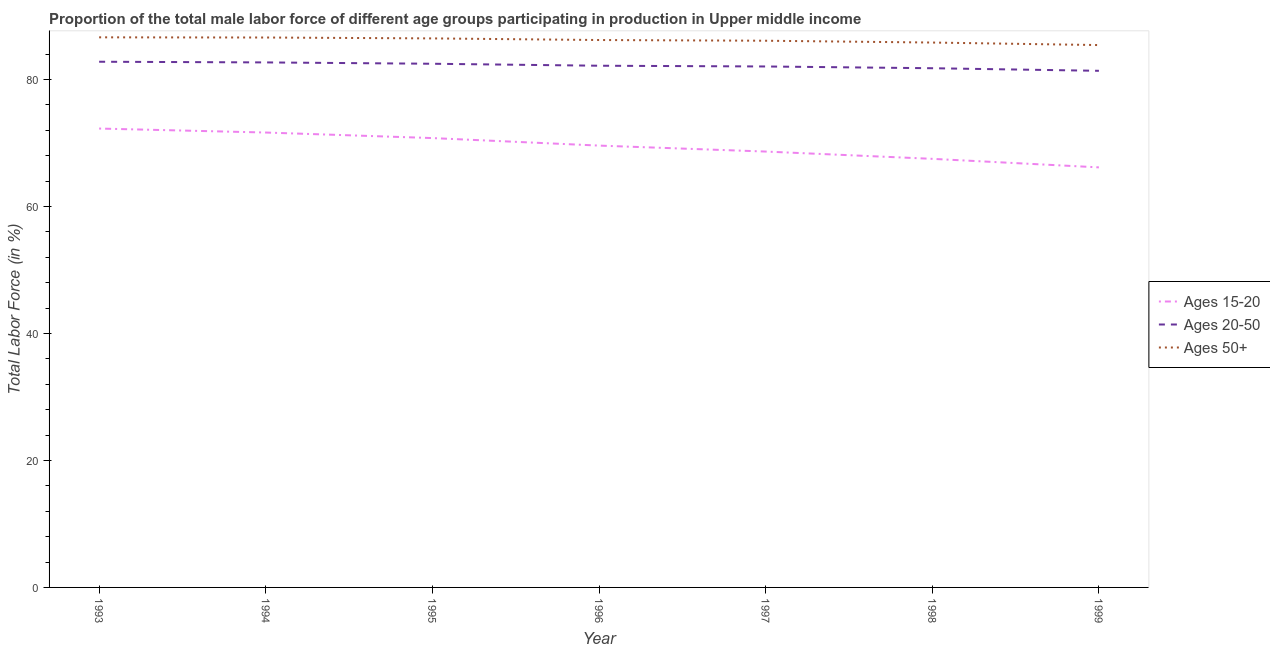What is the percentage of male labor force within the age group 20-50 in 1997?
Provide a short and direct response. 82.04. Across all years, what is the maximum percentage of male labor force above age 50?
Your answer should be compact. 86.63. Across all years, what is the minimum percentage of male labor force within the age group 20-50?
Your answer should be compact. 81.36. In which year was the percentage of male labor force within the age group 15-20 maximum?
Offer a very short reply. 1993. In which year was the percentage of male labor force above age 50 minimum?
Provide a succinct answer. 1999. What is the total percentage of male labor force within the age group 20-50 in the graph?
Provide a short and direct response. 575.24. What is the difference between the percentage of male labor force above age 50 in 1994 and that in 1996?
Your answer should be compact. 0.4. What is the difference between the percentage of male labor force above age 50 in 1994 and the percentage of male labor force within the age group 15-20 in 1993?
Offer a terse response. 14.34. What is the average percentage of male labor force above age 50 per year?
Offer a very short reply. 86.17. In the year 1995, what is the difference between the percentage of male labor force above age 50 and percentage of male labor force within the age group 15-20?
Provide a succinct answer. 15.7. What is the ratio of the percentage of male labor force above age 50 in 1998 to that in 1999?
Offer a terse response. 1. Is the percentage of male labor force within the age group 20-50 in 1997 less than that in 1999?
Offer a very short reply. No. What is the difference between the highest and the second highest percentage of male labor force above age 50?
Your answer should be very brief. 0.03. What is the difference between the highest and the lowest percentage of male labor force within the age group 20-50?
Ensure brevity in your answer.  1.43. Is the sum of the percentage of male labor force within the age group 15-20 in 1993 and 1999 greater than the maximum percentage of male labor force within the age group 20-50 across all years?
Your response must be concise. Yes. Does the percentage of male labor force within the age group 15-20 monotonically increase over the years?
Ensure brevity in your answer.  No. Is the percentage of male labor force within the age group 15-20 strictly greater than the percentage of male labor force within the age group 20-50 over the years?
Make the answer very short. No. Is the percentage of male labor force within the age group 20-50 strictly less than the percentage of male labor force above age 50 over the years?
Give a very brief answer. Yes. How many years are there in the graph?
Make the answer very short. 7. What is the difference between two consecutive major ticks on the Y-axis?
Your answer should be very brief. 20. Does the graph contain any zero values?
Give a very brief answer. No. How are the legend labels stacked?
Ensure brevity in your answer.  Vertical. What is the title of the graph?
Offer a terse response. Proportion of the total male labor force of different age groups participating in production in Upper middle income. What is the label or title of the X-axis?
Offer a terse response. Year. What is the Total Labor Force (in %) of Ages 15-20 in 1993?
Keep it short and to the point. 72.26. What is the Total Labor Force (in %) of Ages 20-50 in 1993?
Keep it short and to the point. 82.78. What is the Total Labor Force (in %) in Ages 50+ in 1993?
Give a very brief answer. 86.63. What is the Total Labor Force (in %) of Ages 15-20 in 1994?
Provide a short and direct response. 71.64. What is the Total Labor Force (in %) of Ages 20-50 in 1994?
Ensure brevity in your answer.  82.68. What is the Total Labor Force (in %) of Ages 50+ in 1994?
Your response must be concise. 86.6. What is the Total Labor Force (in %) of Ages 15-20 in 1995?
Provide a short and direct response. 70.76. What is the Total Labor Force (in %) of Ages 20-50 in 1995?
Offer a terse response. 82.47. What is the Total Labor Force (in %) in Ages 50+ in 1995?
Your answer should be very brief. 86.46. What is the Total Labor Force (in %) of Ages 15-20 in 1996?
Give a very brief answer. 69.58. What is the Total Labor Force (in %) of Ages 20-50 in 1996?
Your answer should be compact. 82.16. What is the Total Labor Force (in %) in Ages 50+ in 1996?
Your answer should be compact. 86.2. What is the Total Labor Force (in %) of Ages 15-20 in 1997?
Give a very brief answer. 68.64. What is the Total Labor Force (in %) of Ages 20-50 in 1997?
Your answer should be very brief. 82.04. What is the Total Labor Force (in %) of Ages 50+ in 1997?
Give a very brief answer. 86.09. What is the Total Labor Force (in %) in Ages 15-20 in 1998?
Provide a short and direct response. 67.49. What is the Total Labor Force (in %) of Ages 20-50 in 1998?
Ensure brevity in your answer.  81.76. What is the Total Labor Force (in %) in Ages 50+ in 1998?
Provide a succinct answer. 85.81. What is the Total Labor Force (in %) in Ages 15-20 in 1999?
Your answer should be very brief. 66.15. What is the Total Labor Force (in %) of Ages 20-50 in 1999?
Offer a terse response. 81.36. What is the Total Labor Force (in %) of Ages 50+ in 1999?
Keep it short and to the point. 85.41. Across all years, what is the maximum Total Labor Force (in %) of Ages 15-20?
Your answer should be very brief. 72.26. Across all years, what is the maximum Total Labor Force (in %) in Ages 20-50?
Your answer should be compact. 82.78. Across all years, what is the maximum Total Labor Force (in %) of Ages 50+?
Your answer should be very brief. 86.63. Across all years, what is the minimum Total Labor Force (in %) in Ages 15-20?
Offer a terse response. 66.15. Across all years, what is the minimum Total Labor Force (in %) of Ages 20-50?
Your answer should be very brief. 81.36. Across all years, what is the minimum Total Labor Force (in %) of Ages 50+?
Offer a very short reply. 85.41. What is the total Total Labor Force (in %) of Ages 15-20 in the graph?
Provide a short and direct response. 486.52. What is the total Total Labor Force (in %) of Ages 20-50 in the graph?
Offer a terse response. 575.24. What is the total Total Labor Force (in %) in Ages 50+ in the graph?
Offer a very short reply. 603.19. What is the difference between the Total Labor Force (in %) of Ages 15-20 in 1993 and that in 1994?
Keep it short and to the point. 0.63. What is the difference between the Total Labor Force (in %) in Ages 20-50 in 1993 and that in 1994?
Keep it short and to the point. 0.11. What is the difference between the Total Labor Force (in %) of Ages 50+ in 1993 and that in 1994?
Ensure brevity in your answer.  0.03. What is the difference between the Total Labor Force (in %) in Ages 15-20 in 1993 and that in 1995?
Keep it short and to the point. 1.5. What is the difference between the Total Labor Force (in %) in Ages 20-50 in 1993 and that in 1995?
Your answer should be very brief. 0.32. What is the difference between the Total Labor Force (in %) of Ages 50+ in 1993 and that in 1995?
Offer a terse response. 0.17. What is the difference between the Total Labor Force (in %) in Ages 15-20 in 1993 and that in 1996?
Keep it short and to the point. 2.68. What is the difference between the Total Labor Force (in %) of Ages 20-50 in 1993 and that in 1996?
Offer a very short reply. 0.63. What is the difference between the Total Labor Force (in %) in Ages 50+ in 1993 and that in 1996?
Make the answer very short. 0.42. What is the difference between the Total Labor Force (in %) in Ages 15-20 in 1993 and that in 1997?
Provide a succinct answer. 3.62. What is the difference between the Total Labor Force (in %) of Ages 20-50 in 1993 and that in 1997?
Give a very brief answer. 0.75. What is the difference between the Total Labor Force (in %) in Ages 50+ in 1993 and that in 1997?
Keep it short and to the point. 0.54. What is the difference between the Total Labor Force (in %) of Ages 15-20 in 1993 and that in 1998?
Your answer should be very brief. 4.77. What is the difference between the Total Labor Force (in %) in Ages 20-50 in 1993 and that in 1998?
Your response must be concise. 1.02. What is the difference between the Total Labor Force (in %) in Ages 50+ in 1993 and that in 1998?
Your response must be concise. 0.82. What is the difference between the Total Labor Force (in %) in Ages 15-20 in 1993 and that in 1999?
Ensure brevity in your answer.  6.12. What is the difference between the Total Labor Force (in %) of Ages 20-50 in 1993 and that in 1999?
Provide a succinct answer. 1.43. What is the difference between the Total Labor Force (in %) of Ages 50+ in 1993 and that in 1999?
Your response must be concise. 1.22. What is the difference between the Total Labor Force (in %) of Ages 15-20 in 1994 and that in 1995?
Keep it short and to the point. 0.87. What is the difference between the Total Labor Force (in %) of Ages 20-50 in 1994 and that in 1995?
Give a very brief answer. 0.21. What is the difference between the Total Labor Force (in %) of Ages 50+ in 1994 and that in 1995?
Provide a short and direct response. 0.14. What is the difference between the Total Labor Force (in %) in Ages 15-20 in 1994 and that in 1996?
Your answer should be very brief. 2.06. What is the difference between the Total Labor Force (in %) of Ages 20-50 in 1994 and that in 1996?
Your answer should be very brief. 0.52. What is the difference between the Total Labor Force (in %) of Ages 50+ in 1994 and that in 1996?
Give a very brief answer. 0.4. What is the difference between the Total Labor Force (in %) in Ages 15-20 in 1994 and that in 1997?
Provide a succinct answer. 3. What is the difference between the Total Labor Force (in %) in Ages 20-50 in 1994 and that in 1997?
Offer a very short reply. 0.64. What is the difference between the Total Labor Force (in %) in Ages 50+ in 1994 and that in 1997?
Give a very brief answer. 0.51. What is the difference between the Total Labor Force (in %) of Ages 15-20 in 1994 and that in 1998?
Make the answer very short. 4.14. What is the difference between the Total Labor Force (in %) of Ages 20-50 in 1994 and that in 1998?
Ensure brevity in your answer.  0.92. What is the difference between the Total Labor Force (in %) of Ages 50+ in 1994 and that in 1998?
Keep it short and to the point. 0.79. What is the difference between the Total Labor Force (in %) in Ages 15-20 in 1994 and that in 1999?
Make the answer very short. 5.49. What is the difference between the Total Labor Force (in %) in Ages 20-50 in 1994 and that in 1999?
Offer a terse response. 1.32. What is the difference between the Total Labor Force (in %) in Ages 50+ in 1994 and that in 1999?
Offer a terse response. 1.19. What is the difference between the Total Labor Force (in %) of Ages 15-20 in 1995 and that in 1996?
Your answer should be compact. 1.18. What is the difference between the Total Labor Force (in %) of Ages 20-50 in 1995 and that in 1996?
Give a very brief answer. 0.31. What is the difference between the Total Labor Force (in %) in Ages 50+ in 1995 and that in 1996?
Your answer should be compact. 0.26. What is the difference between the Total Labor Force (in %) of Ages 15-20 in 1995 and that in 1997?
Provide a succinct answer. 2.12. What is the difference between the Total Labor Force (in %) of Ages 20-50 in 1995 and that in 1997?
Ensure brevity in your answer.  0.43. What is the difference between the Total Labor Force (in %) in Ages 50+ in 1995 and that in 1997?
Your answer should be very brief. 0.37. What is the difference between the Total Labor Force (in %) of Ages 15-20 in 1995 and that in 1998?
Give a very brief answer. 3.27. What is the difference between the Total Labor Force (in %) in Ages 20-50 in 1995 and that in 1998?
Offer a terse response. 0.7. What is the difference between the Total Labor Force (in %) in Ages 50+ in 1995 and that in 1998?
Keep it short and to the point. 0.65. What is the difference between the Total Labor Force (in %) in Ages 15-20 in 1995 and that in 1999?
Your answer should be compact. 4.62. What is the difference between the Total Labor Force (in %) in Ages 20-50 in 1995 and that in 1999?
Your answer should be very brief. 1.11. What is the difference between the Total Labor Force (in %) of Ages 50+ in 1995 and that in 1999?
Make the answer very short. 1.05. What is the difference between the Total Labor Force (in %) of Ages 15-20 in 1996 and that in 1997?
Your answer should be very brief. 0.94. What is the difference between the Total Labor Force (in %) of Ages 20-50 in 1996 and that in 1997?
Offer a terse response. 0.12. What is the difference between the Total Labor Force (in %) in Ages 50+ in 1996 and that in 1997?
Make the answer very short. 0.11. What is the difference between the Total Labor Force (in %) in Ages 15-20 in 1996 and that in 1998?
Offer a very short reply. 2.09. What is the difference between the Total Labor Force (in %) of Ages 20-50 in 1996 and that in 1998?
Give a very brief answer. 0.39. What is the difference between the Total Labor Force (in %) in Ages 50+ in 1996 and that in 1998?
Make the answer very short. 0.4. What is the difference between the Total Labor Force (in %) in Ages 15-20 in 1996 and that in 1999?
Offer a very short reply. 3.43. What is the difference between the Total Labor Force (in %) of Ages 20-50 in 1996 and that in 1999?
Keep it short and to the point. 0.8. What is the difference between the Total Labor Force (in %) in Ages 50+ in 1996 and that in 1999?
Give a very brief answer. 0.79. What is the difference between the Total Labor Force (in %) of Ages 15-20 in 1997 and that in 1998?
Your answer should be very brief. 1.15. What is the difference between the Total Labor Force (in %) of Ages 20-50 in 1997 and that in 1998?
Make the answer very short. 0.28. What is the difference between the Total Labor Force (in %) of Ages 50+ in 1997 and that in 1998?
Make the answer very short. 0.29. What is the difference between the Total Labor Force (in %) of Ages 15-20 in 1997 and that in 1999?
Make the answer very short. 2.49. What is the difference between the Total Labor Force (in %) of Ages 20-50 in 1997 and that in 1999?
Your answer should be very brief. 0.68. What is the difference between the Total Labor Force (in %) of Ages 50+ in 1997 and that in 1999?
Ensure brevity in your answer.  0.68. What is the difference between the Total Labor Force (in %) in Ages 15-20 in 1998 and that in 1999?
Offer a very short reply. 1.35. What is the difference between the Total Labor Force (in %) in Ages 20-50 in 1998 and that in 1999?
Your answer should be very brief. 0.41. What is the difference between the Total Labor Force (in %) in Ages 50+ in 1998 and that in 1999?
Provide a short and direct response. 0.4. What is the difference between the Total Labor Force (in %) of Ages 15-20 in 1993 and the Total Labor Force (in %) of Ages 20-50 in 1994?
Your answer should be compact. -10.41. What is the difference between the Total Labor Force (in %) of Ages 15-20 in 1993 and the Total Labor Force (in %) of Ages 50+ in 1994?
Make the answer very short. -14.34. What is the difference between the Total Labor Force (in %) in Ages 20-50 in 1993 and the Total Labor Force (in %) in Ages 50+ in 1994?
Your answer should be very brief. -3.81. What is the difference between the Total Labor Force (in %) of Ages 15-20 in 1993 and the Total Labor Force (in %) of Ages 20-50 in 1995?
Ensure brevity in your answer.  -10.2. What is the difference between the Total Labor Force (in %) of Ages 15-20 in 1993 and the Total Labor Force (in %) of Ages 50+ in 1995?
Your response must be concise. -14.2. What is the difference between the Total Labor Force (in %) of Ages 20-50 in 1993 and the Total Labor Force (in %) of Ages 50+ in 1995?
Keep it short and to the point. -3.67. What is the difference between the Total Labor Force (in %) of Ages 15-20 in 1993 and the Total Labor Force (in %) of Ages 20-50 in 1996?
Your response must be concise. -9.89. What is the difference between the Total Labor Force (in %) in Ages 15-20 in 1993 and the Total Labor Force (in %) in Ages 50+ in 1996?
Provide a short and direct response. -13.94. What is the difference between the Total Labor Force (in %) in Ages 20-50 in 1993 and the Total Labor Force (in %) in Ages 50+ in 1996?
Keep it short and to the point. -3.42. What is the difference between the Total Labor Force (in %) of Ages 15-20 in 1993 and the Total Labor Force (in %) of Ages 20-50 in 1997?
Your answer should be compact. -9.77. What is the difference between the Total Labor Force (in %) of Ages 15-20 in 1993 and the Total Labor Force (in %) of Ages 50+ in 1997?
Offer a terse response. -13.83. What is the difference between the Total Labor Force (in %) in Ages 20-50 in 1993 and the Total Labor Force (in %) in Ages 50+ in 1997?
Give a very brief answer. -3.31. What is the difference between the Total Labor Force (in %) of Ages 15-20 in 1993 and the Total Labor Force (in %) of Ages 20-50 in 1998?
Keep it short and to the point. -9.5. What is the difference between the Total Labor Force (in %) in Ages 15-20 in 1993 and the Total Labor Force (in %) in Ages 50+ in 1998?
Provide a succinct answer. -13.54. What is the difference between the Total Labor Force (in %) in Ages 20-50 in 1993 and the Total Labor Force (in %) in Ages 50+ in 1998?
Provide a short and direct response. -3.02. What is the difference between the Total Labor Force (in %) in Ages 15-20 in 1993 and the Total Labor Force (in %) in Ages 20-50 in 1999?
Keep it short and to the point. -9.09. What is the difference between the Total Labor Force (in %) in Ages 15-20 in 1993 and the Total Labor Force (in %) in Ages 50+ in 1999?
Offer a terse response. -13.15. What is the difference between the Total Labor Force (in %) in Ages 20-50 in 1993 and the Total Labor Force (in %) in Ages 50+ in 1999?
Make the answer very short. -2.62. What is the difference between the Total Labor Force (in %) in Ages 15-20 in 1994 and the Total Labor Force (in %) in Ages 20-50 in 1995?
Make the answer very short. -10.83. What is the difference between the Total Labor Force (in %) in Ages 15-20 in 1994 and the Total Labor Force (in %) in Ages 50+ in 1995?
Provide a succinct answer. -14.82. What is the difference between the Total Labor Force (in %) of Ages 20-50 in 1994 and the Total Labor Force (in %) of Ages 50+ in 1995?
Provide a short and direct response. -3.78. What is the difference between the Total Labor Force (in %) in Ages 15-20 in 1994 and the Total Labor Force (in %) in Ages 20-50 in 1996?
Make the answer very short. -10.52. What is the difference between the Total Labor Force (in %) of Ages 15-20 in 1994 and the Total Labor Force (in %) of Ages 50+ in 1996?
Make the answer very short. -14.57. What is the difference between the Total Labor Force (in %) of Ages 20-50 in 1994 and the Total Labor Force (in %) of Ages 50+ in 1996?
Provide a short and direct response. -3.53. What is the difference between the Total Labor Force (in %) of Ages 15-20 in 1994 and the Total Labor Force (in %) of Ages 20-50 in 1997?
Provide a succinct answer. -10.4. What is the difference between the Total Labor Force (in %) in Ages 15-20 in 1994 and the Total Labor Force (in %) in Ages 50+ in 1997?
Your answer should be very brief. -14.46. What is the difference between the Total Labor Force (in %) of Ages 20-50 in 1994 and the Total Labor Force (in %) of Ages 50+ in 1997?
Make the answer very short. -3.42. What is the difference between the Total Labor Force (in %) in Ages 15-20 in 1994 and the Total Labor Force (in %) in Ages 20-50 in 1998?
Your response must be concise. -10.13. What is the difference between the Total Labor Force (in %) in Ages 15-20 in 1994 and the Total Labor Force (in %) in Ages 50+ in 1998?
Offer a terse response. -14.17. What is the difference between the Total Labor Force (in %) in Ages 20-50 in 1994 and the Total Labor Force (in %) in Ages 50+ in 1998?
Make the answer very short. -3.13. What is the difference between the Total Labor Force (in %) of Ages 15-20 in 1994 and the Total Labor Force (in %) of Ages 20-50 in 1999?
Your response must be concise. -9.72. What is the difference between the Total Labor Force (in %) of Ages 15-20 in 1994 and the Total Labor Force (in %) of Ages 50+ in 1999?
Provide a succinct answer. -13.77. What is the difference between the Total Labor Force (in %) of Ages 20-50 in 1994 and the Total Labor Force (in %) of Ages 50+ in 1999?
Ensure brevity in your answer.  -2.73. What is the difference between the Total Labor Force (in %) of Ages 15-20 in 1995 and the Total Labor Force (in %) of Ages 20-50 in 1996?
Make the answer very short. -11.39. What is the difference between the Total Labor Force (in %) in Ages 15-20 in 1995 and the Total Labor Force (in %) in Ages 50+ in 1996?
Offer a very short reply. -15.44. What is the difference between the Total Labor Force (in %) of Ages 20-50 in 1995 and the Total Labor Force (in %) of Ages 50+ in 1996?
Provide a succinct answer. -3.74. What is the difference between the Total Labor Force (in %) in Ages 15-20 in 1995 and the Total Labor Force (in %) in Ages 20-50 in 1997?
Keep it short and to the point. -11.27. What is the difference between the Total Labor Force (in %) in Ages 15-20 in 1995 and the Total Labor Force (in %) in Ages 50+ in 1997?
Make the answer very short. -15.33. What is the difference between the Total Labor Force (in %) of Ages 20-50 in 1995 and the Total Labor Force (in %) of Ages 50+ in 1997?
Your answer should be very brief. -3.63. What is the difference between the Total Labor Force (in %) of Ages 15-20 in 1995 and the Total Labor Force (in %) of Ages 20-50 in 1998?
Offer a terse response. -11. What is the difference between the Total Labor Force (in %) of Ages 15-20 in 1995 and the Total Labor Force (in %) of Ages 50+ in 1998?
Your answer should be compact. -15.04. What is the difference between the Total Labor Force (in %) in Ages 20-50 in 1995 and the Total Labor Force (in %) in Ages 50+ in 1998?
Provide a succinct answer. -3.34. What is the difference between the Total Labor Force (in %) of Ages 15-20 in 1995 and the Total Labor Force (in %) of Ages 20-50 in 1999?
Your answer should be compact. -10.59. What is the difference between the Total Labor Force (in %) in Ages 15-20 in 1995 and the Total Labor Force (in %) in Ages 50+ in 1999?
Keep it short and to the point. -14.65. What is the difference between the Total Labor Force (in %) in Ages 20-50 in 1995 and the Total Labor Force (in %) in Ages 50+ in 1999?
Provide a succinct answer. -2.94. What is the difference between the Total Labor Force (in %) in Ages 15-20 in 1996 and the Total Labor Force (in %) in Ages 20-50 in 1997?
Provide a short and direct response. -12.46. What is the difference between the Total Labor Force (in %) of Ages 15-20 in 1996 and the Total Labor Force (in %) of Ages 50+ in 1997?
Your answer should be compact. -16.51. What is the difference between the Total Labor Force (in %) in Ages 20-50 in 1996 and the Total Labor Force (in %) in Ages 50+ in 1997?
Keep it short and to the point. -3.94. What is the difference between the Total Labor Force (in %) of Ages 15-20 in 1996 and the Total Labor Force (in %) of Ages 20-50 in 1998?
Offer a terse response. -12.18. What is the difference between the Total Labor Force (in %) in Ages 15-20 in 1996 and the Total Labor Force (in %) in Ages 50+ in 1998?
Offer a terse response. -16.23. What is the difference between the Total Labor Force (in %) in Ages 20-50 in 1996 and the Total Labor Force (in %) in Ages 50+ in 1998?
Offer a terse response. -3.65. What is the difference between the Total Labor Force (in %) in Ages 15-20 in 1996 and the Total Labor Force (in %) in Ages 20-50 in 1999?
Provide a short and direct response. -11.78. What is the difference between the Total Labor Force (in %) in Ages 15-20 in 1996 and the Total Labor Force (in %) in Ages 50+ in 1999?
Your response must be concise. -15.83. What is the difference between the Total Labor Force (in %) of Ages 20-50 in 1996 and the Total Labor Force (in %) of Ages 50+ in 1999?
Your response must be concise. -3.25. What is the difference between the Total Labor Force (in %) of Ages 15-20 in 1997 and the Total Labor Force (in %) of Ages 20-50 in 1998?
Provide a short and direct response. -13.12. What is the difference between the Total Labor Force (in %) of Ages 15-20 in 1997 and the Total Labor Force (in %) of Ages 50+ in 1998?
Your response must be concise. -17.17. What is the difference between the Total Labor Force (in %) of Ages 20-50 in 1997 and the Total Labor Force (in %) of Ages 50+ in 1998?
Offer a terse response. -3.77. What is the difference between the Total Labor Force (in %) of Ages 15-20 in 1997 and the Total Labor Force (in %) of Ages 20-50 in 1999?
Keep it short and to the point. -12.72. What is the difference between the Total Labor Force (in %) in Ages 15-20 in 1997 and the Total Labor Force (in %) in Ages 50+ in 1999?
Offer a terse response. -16.77. What is the difference between the Total Labor Force (in %) in Ages 20-50 in 1997 and the Total Labor Force (in %) in Ages 50+ in 1999?
Your response must be concise. -3.37. What is the difference between the Total Labor Force (in %) in Ages 15-20 in 1998 and the Total Labor Force (in %) in Ages 20-50 in 1999?
Ensure brevity in your answer.  -13.86. What is the difference between the Total Labor Force (in %) of Ages 15-20 in 1998 and the Total Labor Force (in %) of Ages 50+ in 1999?
Provide a short and direct response. -17.92. What is the difference between the Total Labor Force (in %) in Ages 20-50 in 1998 and the Total Labor Force (in %) in Ages 50+ in 1999?
Ensure brevity in your answer.  -3.65. What is the average Total Labor Force (in %) in Ages 15-20 per year?
Offer a very short reply. 69.5. What is the average Total Labor Force (in %) of Ages 20-50 per year?
Make the answer very short. 82.18. What is the average Total Labor Force (in %) of Ages 50+ per year?
Your response must be concise. 86.17. In the year 1993, what is the difference between the Total Labor Force (in %) of Ages 15-20 and Total Labor Force (in %) of Ages 20-50?
Provide a succinct answer. -10.52. In the year 1993, what is the difference between the Total Labor Force (in %) in Ages 15-20 and Total Labor Force (in %) in Ages 50+?
Provide a succinct answer. -14.36. In the year 1993, what is the difference between the Total Labor Force (in %) of Ages 20-50 and Total Labor Force (in %) of Ages 50+?
Offer a terse response. -3.84. In the year 1994, what is the difference between the Total Labor Force (in %) in Ages 15-20 and Total Labor Force (in %) in Ages 20-50?
Offer a very short reply. -11.04. In the year 1994, what is the difference between the Total Labor Force (in %) in Ages 15-20 and Total Labor Force (in %) in Ages 50+?
Provide a short and direct response. -14.96. In the year 1994, what is the difference between the Total Labor Force (in %) of Ages 20-50 and Total Labor Force (in %) of Ages 50+?
Your answer should be very brief. -3.92. In the year 1995, what is the difference between the Total Labor Force (in %) in Ages 15-20 and Total Labor Force (in %) in Ages 20-50?
Keep it short and to the point. -11.7. In the year 1995, what is the difference between the Total Labor Force (in %) in Ages 15-20 and Total Labor Force (in %) in Ages 50+?
Your answer should be very brief. -15.7. In the year 1995, what is the difference between the Total Labor Force (in %) in Ages 20-50 and Total Labor Force (in %) in Ages 50+?
Your answer should be very brief. -3.99. In the year 1996, what is the difference between the Total Labor Force (in %) of Ages 15-20 and Total Labor Force (in %) of Ages 20-50?
Your answer should be very brief. -12.58. In the year 1996, what is the difference between the Total Labor Force (in %) of Ages 15-20 and Total Labor Force (in %) of Ages 50+?
Keep it short and to the point. -16.62. In the year 1996, what is the difference between the Total Labor Force (in %) in Ages 20-50 and Total Labor Force (in %) in Ages 50+?
Your answer should be very brief. -4.05. In the year 1997, what is the difference between the Total Labor Force (in %) of Ages 15-20 and Total Labor Force (in %) of Ages 20-50?
Your answer should be very brief. -13.4. In the year 1997, what is the difference between the Total Labor Force (in %) in Ages 15-20 and Total Labor Force (in %) in Ages 50+?
Your answer should be very brief. -17.45. In the year 1997, what is the difference between the Total Labor Force (in %) in Ages 20-50 and Total Labor Force (in %) in Ages 50+?
Your answer should be very brief. -4.05. In the year 1998, what is the difference between the Total Labor Force (in %) of Ages 15-20 and Total Labor Force (in %) of Ages 20-50?
Make the answer very short. -14.27. In the year 1998, what is the difference between the Total Labor Force (in %) of Ages 15-20 and Total Labor Force (in %) of Ages 50+?
Your answer should be compact. -18.31. In the year 1998, what is the difference between the Total Labor Force (in %) in Ages 20-50 and Total Labor Force (in %) in Ages 50+?
Your answer should be very brief. -4.04. In the year 1999, what is the difference between the Total Labor Force (in %) in Ages 15-20 and Total Labor Force (in %) in Ages 20-50?
Make the answer very short. -15.21. In the year 1999, what is the difference between the Total Labor Force (in %) of Ages 15-20 and Total Labor Force (in %) of Ages 50+?
Your answer should be very brief. -19.26. In the year 1999, what is the difference between the Total Labor Force (in %) in Ages 20-50 and Total Labor Force (in %) in Ages 50+?
Provide a succinct answer. -4.05. What is the ratio of the Total Labor Force (in %) of Ages 15-20 in 1993 to that in 1994?
Offer a very short reply. 1.01. What is the ratio of the Total Labor Force (in %) of Ages 50+ in 1993 to that in 1994?
Offer a very short reply. 1. What is the ratio of the Total Labor Force (in %) of Ages 15-20 in 1993 to that in 1995?
Offer a terse response. 1.02. What is the ratio of the Total Labor Force (in %) in Ages 15-20 in 1993 to that in 1996?
Give a very brief answer. 1.04. What is the ratio of the Total Labor Force (in %) of Ages 20-50 in 1993 to that in 1996?
Your answer should be very brief. 1.01. What is the ratio of the Total Labor Force (in %) of Ages 50+ in 1993 to that in 1996?
Offer a very short reply. 1. What is the ratio of the Total Labor Force (in %) in Ages 15-20 in 1993 to that in 1997?
Your answer should be very brief. 1.05. What is the ratio of the Total Labor Force (in %) of Ages 20-50 in 1993 to that in 1997?
Your response must be concise. 1.01. What is the ratio of the Total Labor Force (in %) in Ages 50+ in 1993 to that in 1997?
Give a very brief answer. 1.01. What is the ratio of the Total Labor Force (in %) of Ages 15-20 in 1993 to that in 1998?
Provide a succinct answer. 1.07. What is the ratio of the Total Labor Force (in %) of Ages 20-50 in 1993 to that in 1998?
Provide a short and direct response. 1.01. What is the ratio of the Total Labor Force (in %) in Ages 50+ in 1993 to that in 1998?
Ensure brevity in your answer.  1.01. What is the ratio of the Total Labor Force (in %) of Ages 15-20 in 1993 to that in 1999?
Your response must be concise. 1.09. What is the ratio of the Total Labor Force (in %) of Ages 20-50 in 1993 to that in 1999?
Keep it short and to the point. 1.02. What is the ratio of the Total Labor Force (in %) of Ages 50+ in 1993 to that in 1999?
Keep it short and to the point. 1.01. What is the ratio of the Total Labor Force (in %) of Ages 15-20 in 1994 to that in 1995?
Ensure brevity in your answer.  1.01. What is the ratio of the Total Labor Force (in %) in Ages 20-50 in 1994 to that in 1995?
Offer a very short reply. 1. What is the ratio of the Total Labor Force (in %) of Ages 15-20 in 1994 to that in 1996?
Your answer should be compact. 1.03. What is the ratio of the Total Labor Force (in %) of Ages 20-50 in 1994 to that in 1996?
Your response must be concise. 1.01. What is the ratio of the Total Labor Force (in %) of Ages 15-20 in 1994 to that in 1997?
Make the answer very short. 1.04. What is the ratio of the Total Labor Force (in %) in Ages 20-50 in 1994 to that in 1997?
Your answer should be very brief. 1.01. What is the ratio of the Total Labor Force (in %) in Ages 50+ in 1994 to that in 1997?
Make the answer very short. 1.01. What is the ratio of the Total Labor Force (in %) in Ages 15-20 in 1994 to that in 1998?
Ensure brevity in your answer.  1.06. What is the ratio of the Total Labor Force (in %) of Ages 20-50 in 1994 to that in 1998?
Make the answer very short. 1.01. What is the ratio of the Total Labor Force (in %) in Ages 50+ in 1994 to that in 1998?
Offer a very short reply. 1.01. What is the ratio of the Total Labor Force (in %) of Ages 15-20 in 1994 to that in 1999?
Make the answer very short. 1.08. What is the ratio of the Total Labor Force (in %) of Ages 20-50 in 1994 to that in 1999?
Give a very brief answer. 1.02. What is the ratio of the Total Labor Force (in %) of Ages 50+ in 1994 to that in 1999?
Make the answer very short. 1.01. What is the ratio of the Total Labor Force (in %) of Ages 15-20 in 1995 to that in 1996?
Provide a short and direct response. 1.02. What is the ratio of the Total Labor Force (in %) in Ages 50+ in 1995 to that in 1996?
Offer a terse response. 1. What is the ratio of the Total Labor Force (in %) in Ages 15-20 in 1995 to that in 1997?
Ensure brevity in your answer.  1.03. What is the ratio of the Total Labor Force (in %) in Ages 15-20 in 1995 to that in 1998?
Provide a short and direct response. 1.05. What is the ratio of the Total Labor Force (in %) of Ages 20-50 in 1995 to that in 1998?
Offer a terse response. 1.01. What is the ratio of the Total Labor Force (in %) in Ages 50+ in 1995 to that in 1998?
Provide a succinct answer. 1.01. What is the ratio of the Total Labor Force (in %) in Ages 15-20 in 1995 to that in 1999?
Your answer should be very brief. 1.07. What is the ratio of the Total Labor Force (in %) of Ages 20-50 in 1995 to that in 1999?
Provide a succinct answer. 1.01. What is the ratio of the Total Labor Force (in %) in Ages 50+ in 1995 to that in 1999?
Make the answer very short. 1.01. What is the ratio of the Total Labor Force (in %) of Ages 15-20 in 1996 to that in 1997?
Your response must be concise. 1.01. What is the ratio of the Total Labor Force (in %) of Ages 20-50 in 1996 to that in 1997?
Give a very brief answer. 1. What is the ratio of the Total Labor Force (in %) in Ages 15-20 in 1996 to that in 1998?
Keep it short and to the point. 1.03. What is the ratio of the Total Labor Force (in %) in Ages 50+ in 1996 to that in 1998?
Give a very brief answer. 1. What is the ratio of the Total Labor Force (in %) in Ages 15-20 in 1996 to that in 1999?
Your answer should be very brief. 1.05. What is the ratio of the Total Labor Force (in %) of Ages 20-50 in 1996 to that in 1999?
Make the answer very short. 1.01. What is the ratio of the Total Labor Force (in %) of Ages 50+ in 1996 to that in 1999?
Keep it short and to the point. 1.01. What is the ratio of the Total Labor Force (in %) in Ages 15-20 in 1997 to that in 1998?
Ensure brevity in your answer.  1.02. What is the ratio of the Total Labor Force (in %) in Ages 50+ in 1997 to that in 1998?
Make the answer very short. 1. What is the ratio of the Total Labor Force (in %) in Ages 15-20 in 1997 to that in 1999?
Provide a short and direct response. 1.04. What is the ratio of the Total Labor Force (in %) in Ages 20-50 in 1997 to that in 1999?
Make the answer very short. 1.01. What is the ratio of the Total Labor Force (in %) of Ages 15-20 in 1998 to that in 1999?
Give a very brief answer. 1.02. What is the ratio of the Total Labor Force (in %) in Ages 20-50 in 1998 to that in 1999?
Provide a short and direct response. 1. What is the difference between the highest and the second highest Total Labor Force (in %) of Ages 15-20?
Provide a succinct answer. 0.63. What is the difference between the highest and the second highest Total Labor Force (in %) in Ages 20-50?
Keep it short and to the point. 0.11. What is the difference between the highest and the second highest Total Labor Force (in %) of Ages 50+?
Give a very brief answer. 0.03. What is the difference between the highest and the lowest Total Labor Force (in %) of Ages 15-20?
Offer a very short reply. 6.12. What is the difference between the highest and the lowest Total Labor Force (in %) in Ages 20-50?
Keep it short and to the point. 1.43. What is the difference between the highest and the lowest Total Labor Force (in %) in Ages 50+?
Your response must be concise. 1.22. 